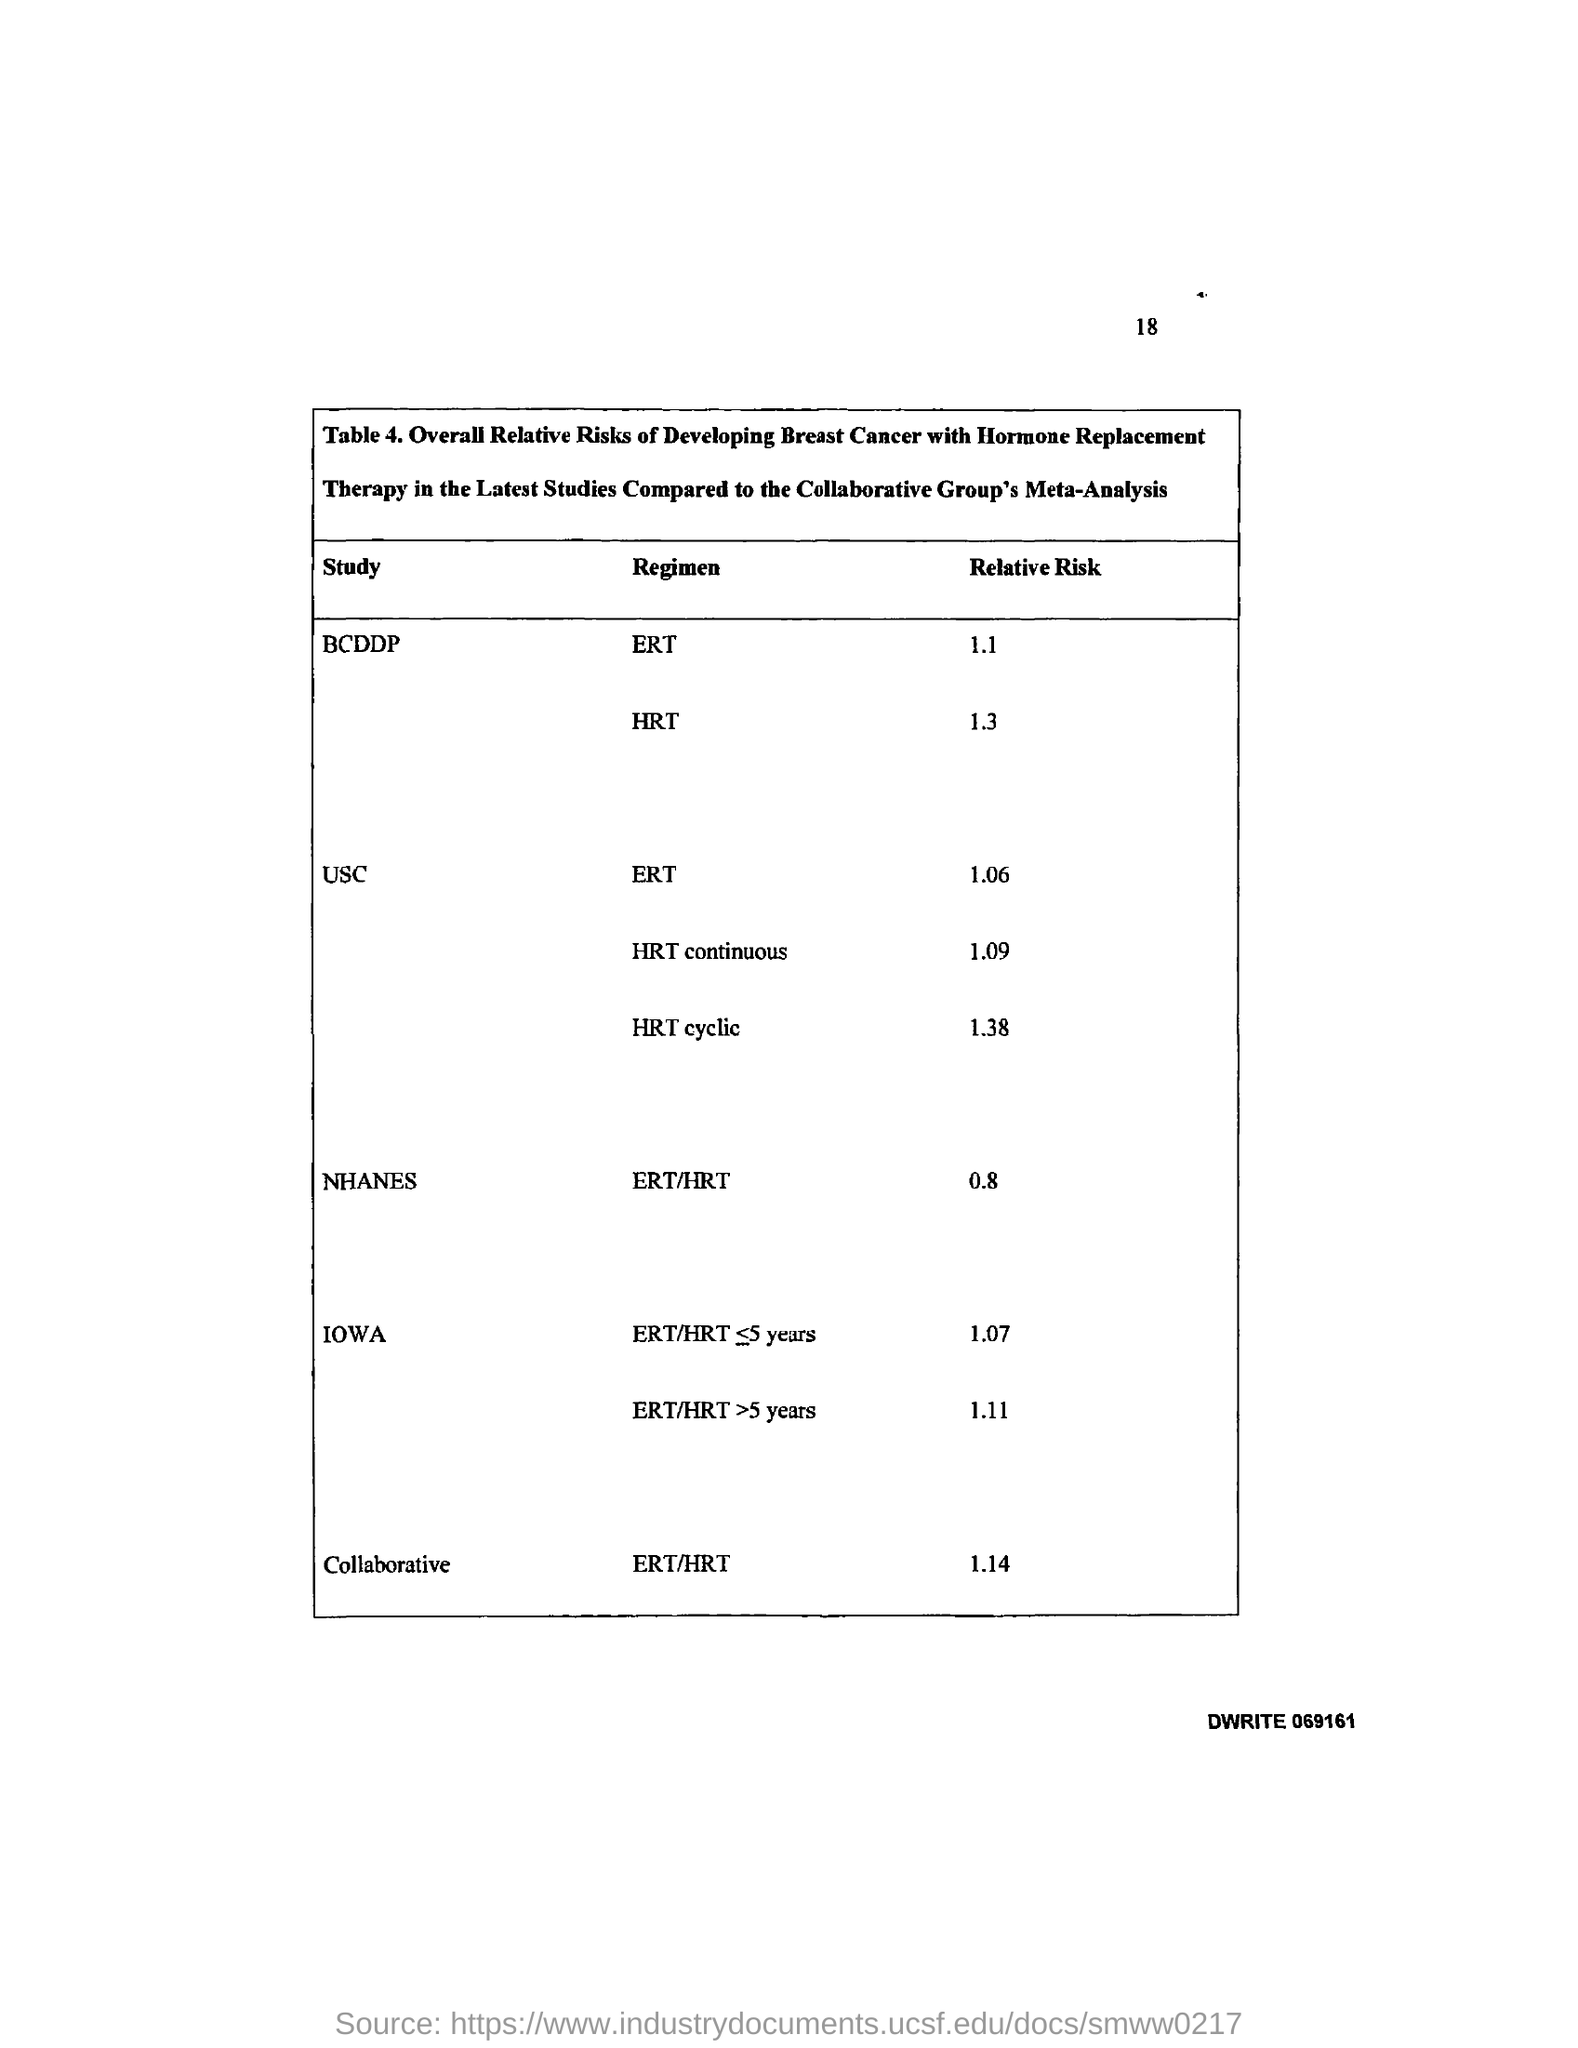What is the Page Number?
Your response must be concise. 18. 